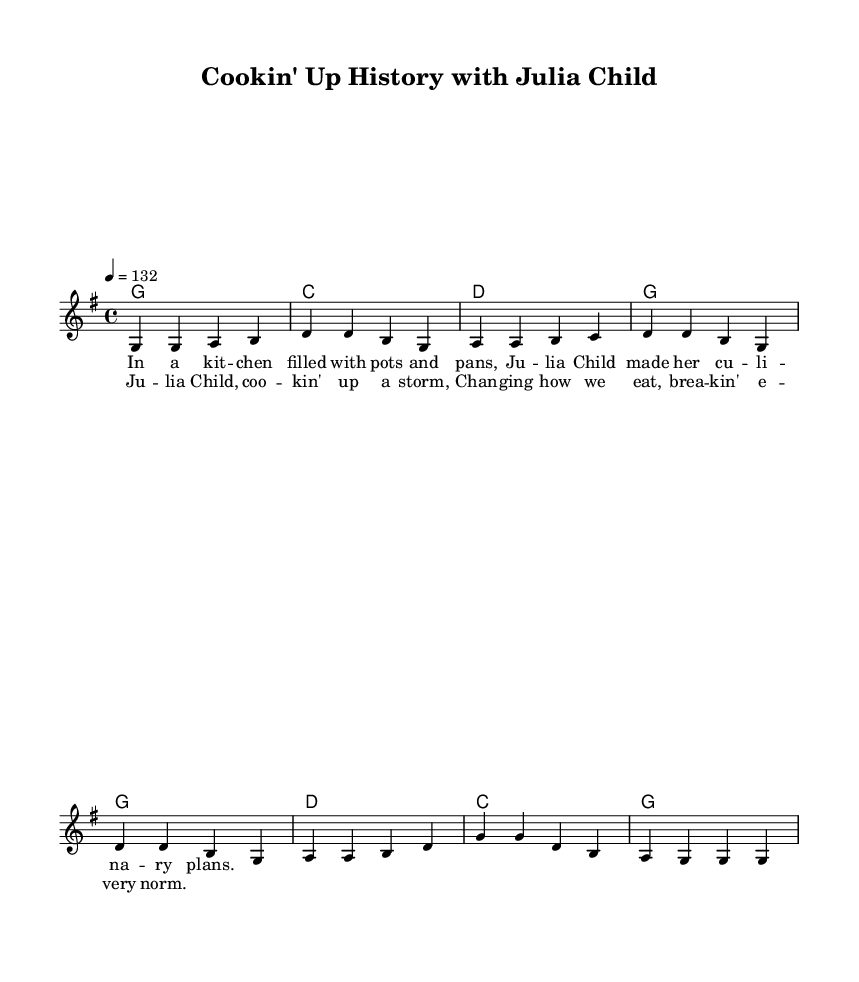What is the key signature of this music? The key signature indicates that this piece is in G major, which is represented by one sharp (F#). This information is found at the beginning of the staff and confirms the tonality throughout the piece.
Answer: G major What is the time signature of this music? The time signature shown at the beginning of the score is 4/4. This means there are four beats per measure and a quarter note receives one beat, which is common in country rock music.
Answer: 4/4 What is the tempo marking for this piece? The tempo marking "4 = 132" specifies that there are 132 beats per minute with the quarter note. This suggests an upbeat and lively pace appropriate for an energetic country rock tune.
Answer: 132 How many measures are in the verse section? Counting the musical notation for the verse, there are four measures in total, as indicated by the bars separating the phrases. Each phrase in the verse is organized within its own measure.
Answer: 4 What is the main theme of the chorus lyrics? The chorus lyrics reflect the contributions of Julia Child to American cuisine, indicating her role in changing eating habits and culinary practices, which aligns with the historical celebration theme of the song.
Answer: Julia Child What chord follows the G major chord in the verse? In the chord progression of the verse, after the G major chord, the next chord is C major, as indicated in the chord mode section. This progression contributes to the typical sound of country rock music.
Answer: C major What is the function of the lyrics in the song? The lyrics serve to narrate a story about Julia Child, celebrating her impact on American cooking, while complementing the upbeat melodies typical of country rock, creating an engaging narrative for the audience.
Answer: To celebrate Julia Child 